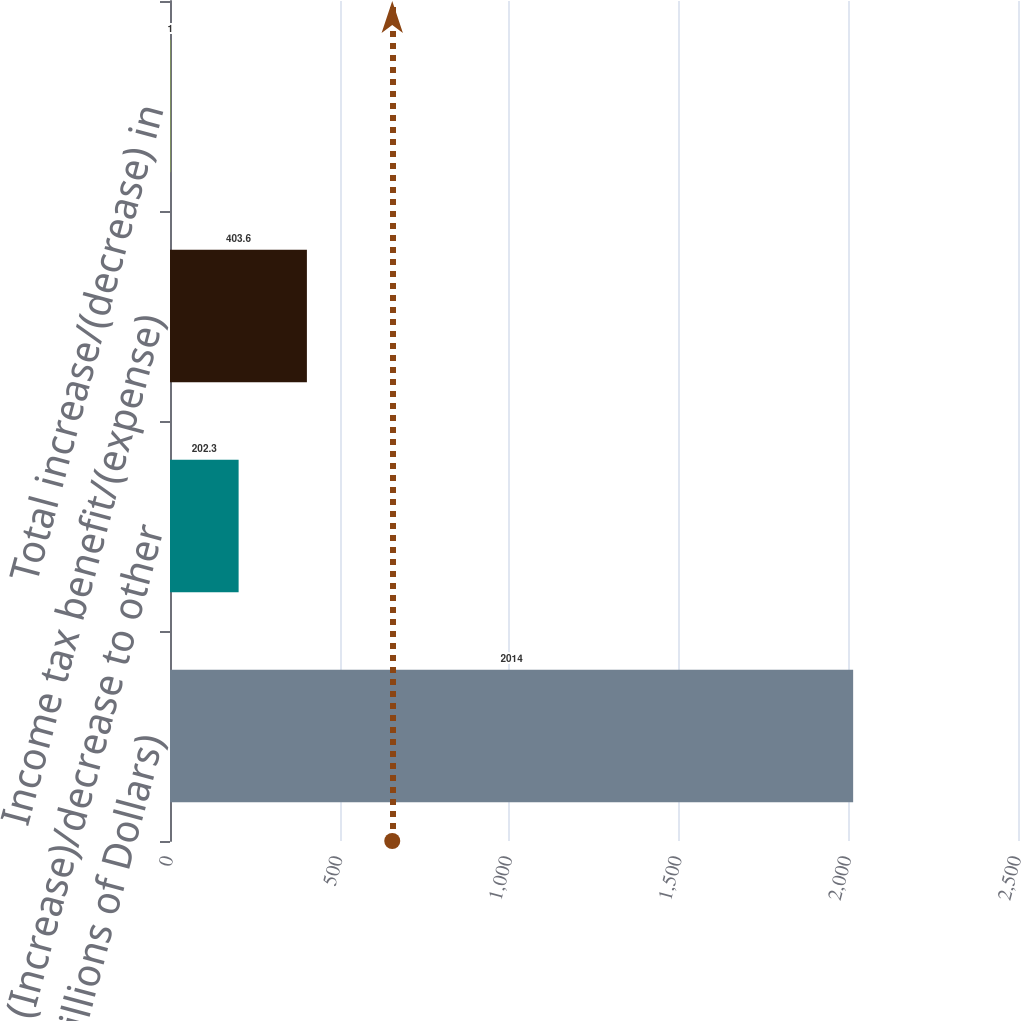<chart> <loc_0><loc_0><loc_500><loc_500><bar_chart><fcel>(Millions of Dollars)<fcel>(Increase)/decrease to other<fcel>Income tax benefit/(expense)<fcel>Total increase/(decrease) in<nl><fcel>2014<fcel>202.3<fcel>403.6<fcel>1<nl></chart> 